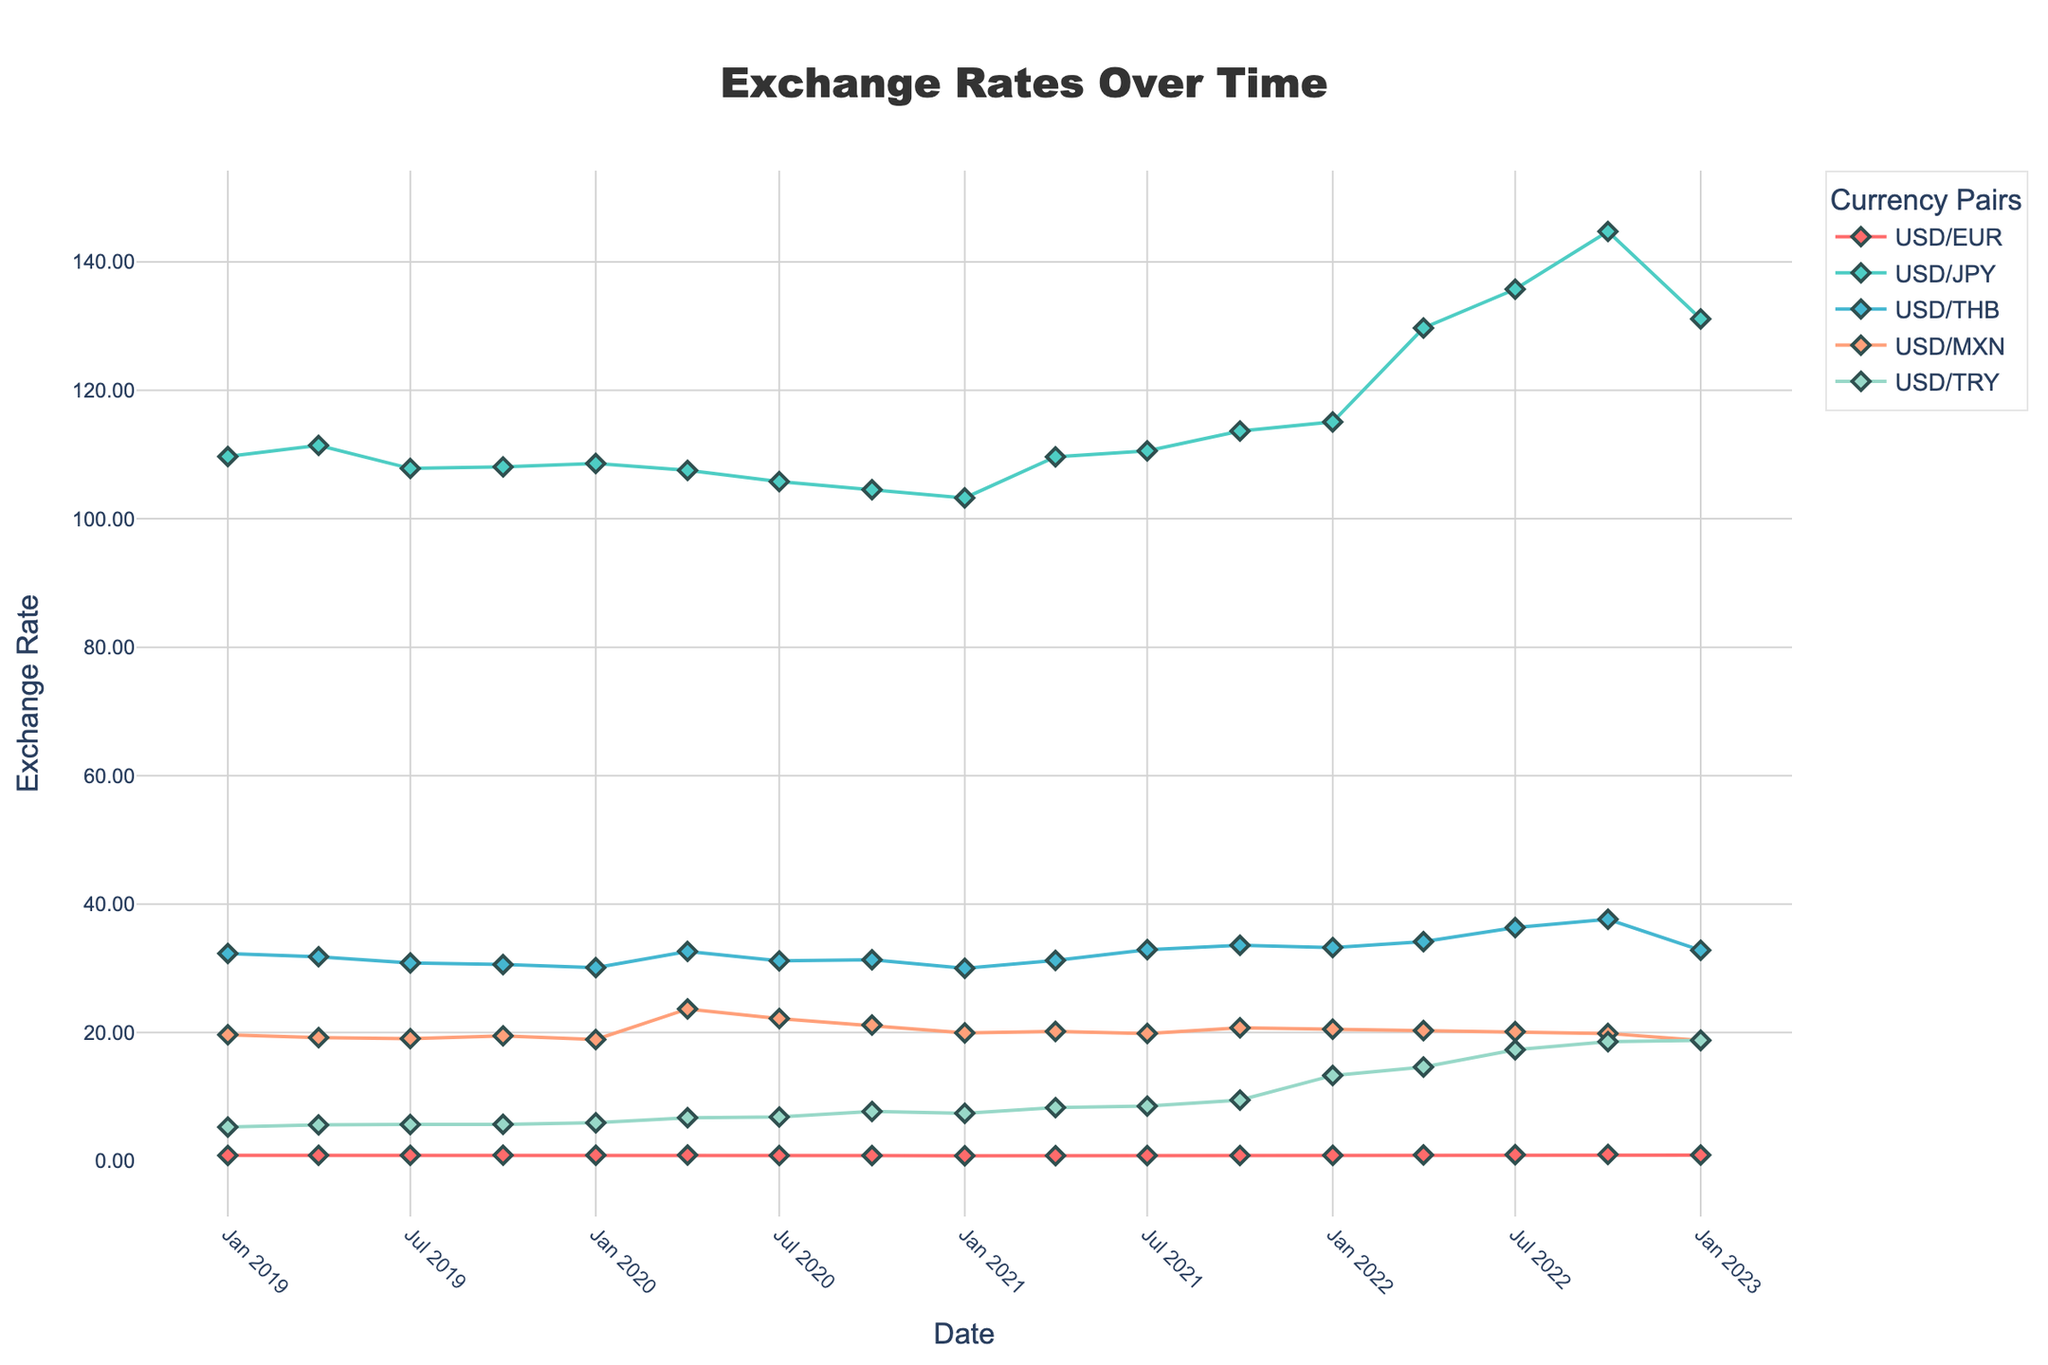What was the USD/THB exchange rate around the end of 2019? Look for the USD/THB line corresponding to the end of 2019 on the x-axis and find the y-value. In October 2019, it was around 30.59.
Answer: 30.59 How did the USD/TRY exchange rate change between January 2022 and October 2022? Identify the data points for USD/TRY in January 2022 and October 2022. Compare the two values (13.31 and 18.58, respectively). The exchange rate increased significantly.
Answer: Increased Which currency had the most significant increase in exchange rate over the entire period shown? To determine this, compare the start and end points for each currency pair on the y-axis. USD/TRY shows the biggest increase from approximately 5.29 to 18.79.
Answer: USD/TRY Between April 2020 and July 2020, which of the currencies saw a decrease in exchange rate? Compare the y-values of each currency's line at April 2020 and July 2020. USD/EUR, USD/JPY, and USD/THB all decreased during this period.
Answer: USD/EUR, USD/JPY, USD/THB What is the average exchange rate of USD/EUR in the year 2022? Find the data points for USD/EUR in 2022 (0.88, 0.95, 0.98, 1.02), sum them (0.88 + 0.95 + 0.98 + 1.02 = 3.83) and divide by the number of points (3.83 / 4 = 0.9575).
Answer: 0.9575 How did the USD/MXN exchange rate fluctuate between January 2020 and January 2021? Identify the data points for USD/MXN from January 2020 to January 2021. The rates are 18.91, 23.67, 22.18, 21.16, and 19.95, showing a peak in April 2020 and then a general decrease.
Answer: Peaked then decreased What was the trend of the USD/JPY exchange rate for the year 2021? Check the values of USD/JPY for all four quarters of 2021, which are increasing from 103.25 in January to 113.67 in October, showing an overall upward trend.
Answer: Upward trend How does the shape of the USD/TRY line compare to the USD/JPY line over the entire period? Visually compare the two lines. The USD/TRY line shows a steep and steady increase, while the USD/JPY line exhibits smaller fluctuations and a gradual increase.
Answer: Steep increase vs. gradual increase 